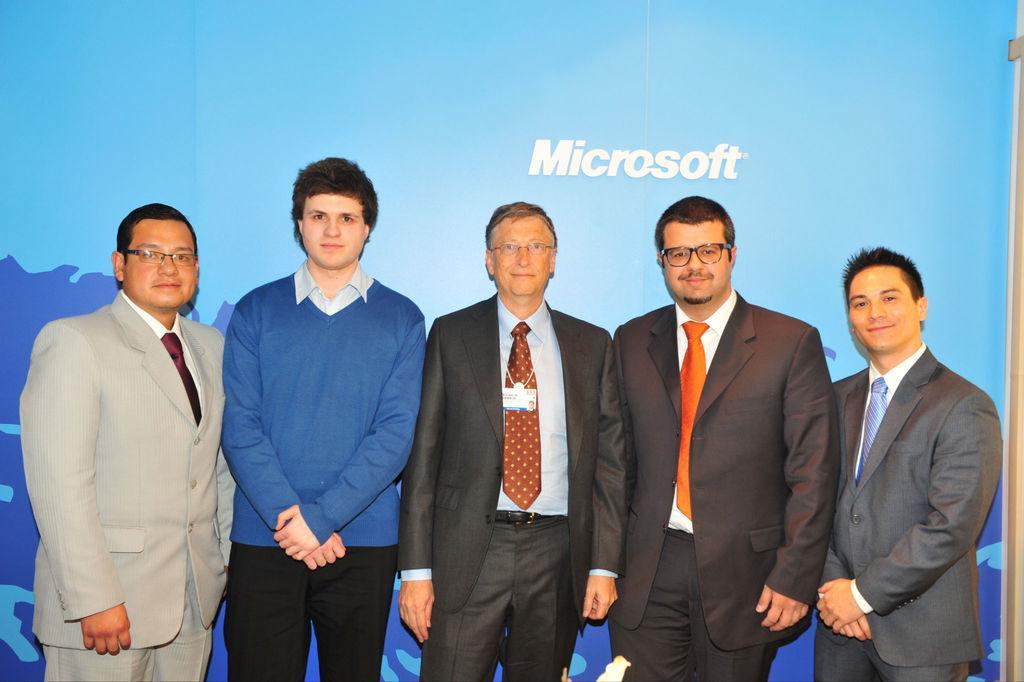Could you give a brief overview of what you see in this image? This picture shows few people standing and we see hoarding on the back and we see few people wore spectacles on their faces. They wore coats with the ties on their neck and we see a id card to one of the man's neck. 